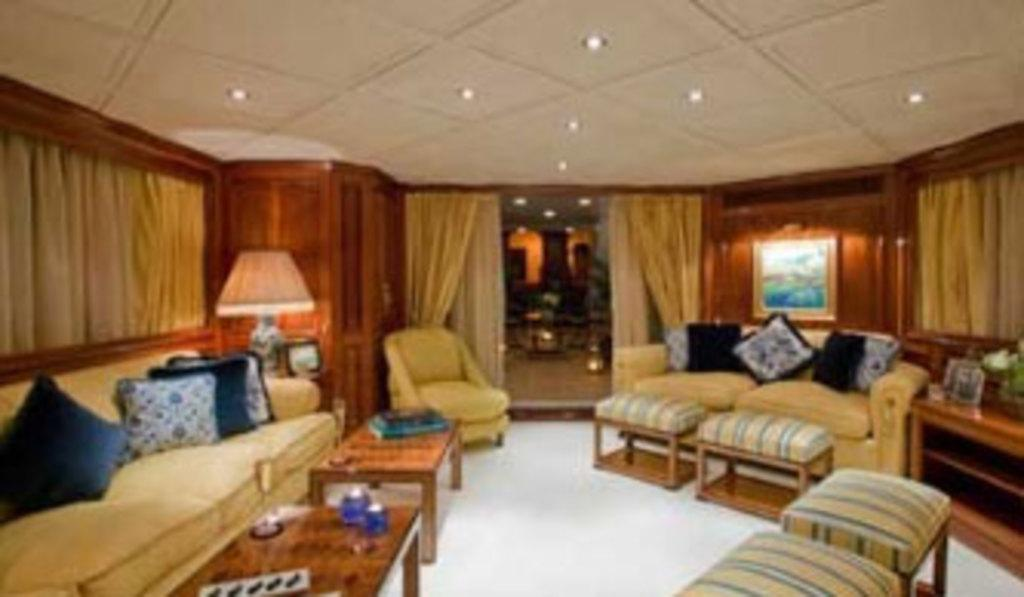How many sofas are in the image? There are two sofas in the image. What is on the sofas? There are cushions on the sofas. What other furniture is in the image? There are tables in the image. What type of window treatment is present in the image? There are curtains on the windows. What is the purpose of the door in the image? The door in the image is likely for entering or exiting the room. What type of dress is hanging on the bridge in the image? There is no bridge or dress present in the image. 